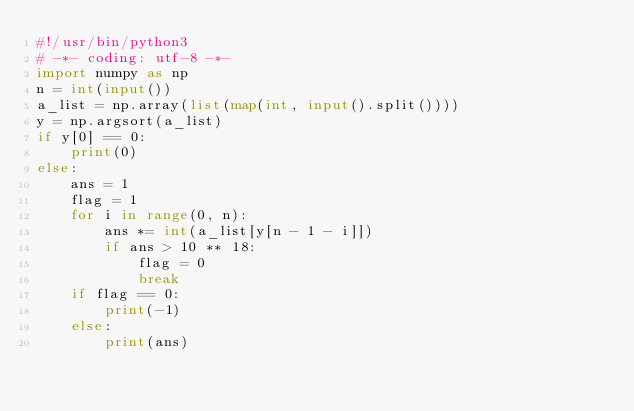Convert code to text. <code><loc_0><loc_0><loc_500><loc_500><_Python_>#!/usr/bin/python3
# -*- coding: utf-8 -*-
import numpy as np
n = int(input())
a_list = np.array(list(map(int, input().split())))
y = np.argsort(a_list)
if y[0] == 0:
    print(0)
else:
    ans = 1
    flag = 1
    for i in range(0, n):
        ans *= int(a_list[y[n - 1 - i]])
        if ans > 10 ** 18:
            flag = 0
            break
    if flag == 0:
        print(-1)
    else:
        print(ans)

</code> 